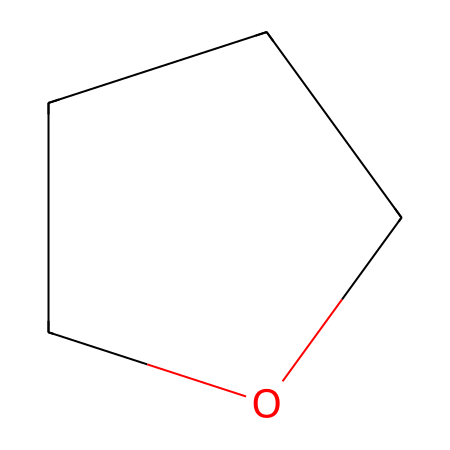What is the molecular formula of tetrahydrofuran? To determine the molecular formula, count the number of each type of atom in the structure. The structure C1CCCO1 shows 4 carbon atoms (C) and 8 hydrogen atoms (H), with no other elements present. Therefore, the molecular formula is C4H8O.
Answer: C4H8O How many carbon atoms are in tetrahydrofuran? By examining the structure represented by the SMILES notation, we see that there are 4 carbon atoms indicated in the chemical formula.
Answer: 4 What type of functional group is present in tetrahydrofuran? Tetrahydrofuran contains an ether functional group as indicated by the presence of oxygen bonded to carbon within its cyclic structure.
Answer: ether How many hydrogen atoms are there in tetrahydrofuran? To find the number of hydrogen atoms, observe the structure and count them. In C1CCCO1, there are a total of 8 hydrogen atoms associated with the 4 carbon atoms and the ether oxygen.
Answer: 8 Is tetrahydrofuran a polar or nonpolar solvent? Tetrahydrofuran has an oxygen atom that leads to its polar characteristics; however, the overall structure is relatively symmetrical, giving it nonpolar properties in many scenarios. Thus, it is often classified as a polar aprotic solvent.
Answer: polar aprotic 